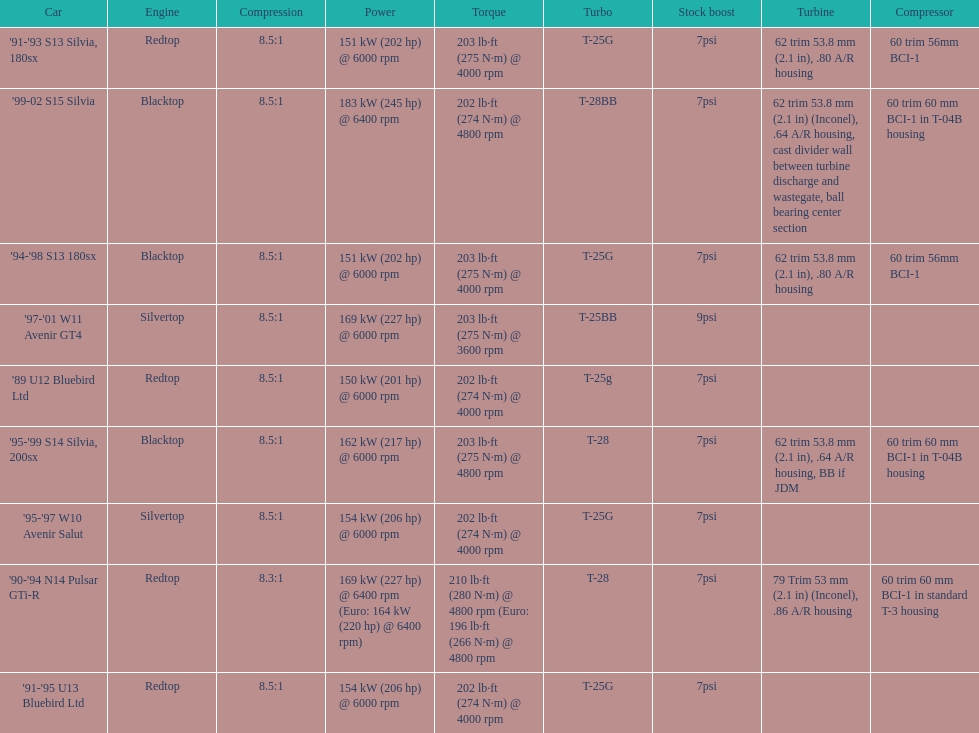Which engine(s) has the least amount of power? Redtop. Help me parse the entirety of this table. {'header': ['Car', 'Engine', 'Compression', 'Power', 'Torque', 'Turbo', 'Stock boost', 'Turbine', 'Compressor'], 'rows': [["'91-'93 S13 Silvia, 180sx", 'Redtop', '8.5:1', '151\xa0kW (202\xa0hp) @ 6000 rpm', '203\xa0lb·ft (275\xa0N·m) @ 4000 rpm', 'T-25G', '7psi', '62 trim 53.8\xa0mm (2.1\xa0in), .80 A/R housing', '60 trim 56mm BCI-1'], ["'99-02 S15 Silvia", 'Blacktop', '8.5:1', '183\xa0kW (245\xa0hp) @ 6400 rpm', '202\xa0lb·ft (274\xa0N·m) @ 4800 rpm', 'T-28BB', '7psi', '62 trim 53.8\xa0mm (2.1\xa0in) (Inconel), .64 A/R housing, cast divider wall between turbine discharge and wastegate, ball bearing center section', '60 trim 60\xa0mm BCI-1 in T-04B housing'], ["'94-'98 S13 180sx", 'Blacktop', '8.5:1', '151\xa0kW (202\xa0hp) @ 6000 rpm', '203\xa0lb·ft (275\xa0N·m) @ 4000 rpm', 'T-25G', '7psi', '62 trim 53.8\xa0mm (2.1\xa0in), .80 A/R housing', '60 trim 56mm BCI-1'], ["'97-'01 W11 Avenir GT4", 'Silvertop', '8.5:1', '169\xa0kW (227\xa0hp) @ 6000 rpm', '203\xa0lb·ft (275\xa0N·m) @ 3600 rpm', 'T-25BB', '9psi', '', ''], ["'89 U12 Bluebird Ltd", 'Redtop', '8.5:1', '150\xa0kW (201\xa0hp) @ 6000 rpm', '202\xa0lb·ft (274\xa0N·m) @ 4000 rpm', 'T-25g', '7psi', '', ''], ["'95-'99 S14 Silvia, 200sx", 'Blacktop', '8.5:1', '162\xa0kW (217\xa0hp) @ 6000 rpm', '203\xa0lb·ft (275\xa0N·m) @ 4800 rpm', 'T-28', '7psi', '62 trim 53.8\xa0mm (2.1\xa0in), .64 A/R housing, BB if JDM', '60 trim 60\xa0mm BCI-1 in T-04B housing'], ["'95-'97 W10 Avenir Salut", 'Silvertop', '8.5:1', '154\xa0kW (206\xa0hp) @ 6000 rpm', '202\xa0lb·ft (274\xa0N·m) @ 4000 rpm', 'T-25G', '7psi', '', ''], ["'90-'94 N14 Pulsar GTi-R", 'Redtop', '8.3:1', '169\xa0kW (227\xa0hp) @ 6400 rpm (Euro: 164\xa0kW (220\xa0hp) @ 6400 rpm)', '210\xa0lb·ft (280\xa0N·m) @ 4800 rpm (Euro: 196\xa0lb·ft (266\xa0N·m) @ 4800 rpm', 'T-28', '7psi', '79 Trim 53\xa0mm (2.1\xa0in) (Inconel), .86 A/R housing', '60 trim 60\xa0mm BCI-1 in standard T-3 housing'], ["'91-'95 U13 Bluebird Ltd", 'Redtop', '8.5:1', '154\xa0kW (206\xa0hp) @ 6000 rpm', '202\xa0lb·ft (274\xa0N·m) @ 4000 rpm', 'T-25G', '7psi', '', '']]} 